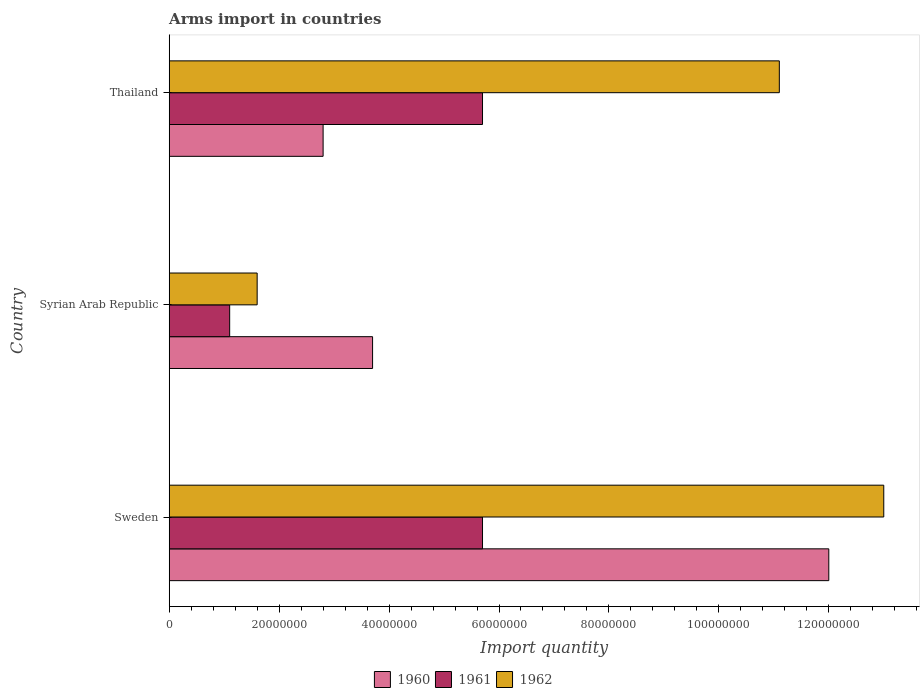How many bars are there on the 1st tick from the top?
Make the answer very short. 3. What is the label of the 3rd group of bars from the top?
Offer a terse response. Sweden. In how many cases, is the number of bars for a given country not equal to the number of legend labels?
Offer a terse response. 0. What is the total arms import in 1960 in Thailand?
Your answer should be very brief. 2.80e+07. Across all countries, what is the maximum total arms import in 1960?
Ensure brevity in your answer.  1.20e+08. Across all countries, what is the minimum total arms import in 1960?
Offer a terse response. 2.80e+07. In which country was the total arms import in 1962 minimum?
Your response must be concise. Syrian Arab Republic. What is the total total arms import in 1960 in the graph?
Your answer should be compact. 1.85e+08. What is the difference between the total arms import in 1962 in Thailand and the total arms import in 1960 in Syrian Arab Republic?
Make the answer very short. 7.40e+07. What is the average total arms import in 1961 per country?
Provide a succinct answer. 4.17e+07. What is the difference between the total arms import in 1960 and total arms import in 1962 in Thailand?
Make the answer very short. -8.30e+07. In how many countries, is the total arms import in 1960 greater than 120000000 ?
Provide a short and direct response. 0. What is the ratio of the total arms import in 1962 in Syrian Arab Republic to that in Thailand?
Offer a terse response. 0.14. What is the difference between the highest and the second highest total arms import in 1960?
Keep it short and to the point. 8.30e+07. What is the difference between the highest and the lowest total arms import in 1960?
Your answer should be compact. 9.20e+07. In how many countries, is the total arms import in 1962 greater than the average total arms import in 1962 taken over all countries?
Offer a very short reply. 2. Is the sum of the total arms import in 1961 in Sweden and Thailand greater than the maximum total arms import in 1962 across all countries?
Your answer should be very brief. No. How many bars are there?
Your response must be concise. 9. What is the difference between two consecutive major ticks on the X-axis?
Your response must be concise. 2.00e+07. Does the graph contain grids?
Your answer should be very brief. No. Where does the legend appear in the graph?
Ensure brevity in your answer.  Bottom center. How many legend labels are there?
Ensure brevity in your answer.  3. How are the legend labels stacked?
Your answer should be very brief. Horizontal. What is the title of the graph?
Offer a very short reply. Arms import in countries. What is the label or title of the X-axis?
Offer a very short reply. Import quantity. What is the label or title of the Y-axis?
Your response must be concise. Country. What is the Import quantity of 1960 in Sweden?
Your response must be concise. 1.20e+08. What is the Import quantity of 1961 in Sweden?
Make the answer very short. 5.70e+07. What is the Import quantity in 1962 in Sweden?
Provide a short and direct response. 1.30e+08. What is the Import quantity in 1960 in Syrian Arab Republic?
Provide a short and direct response. 3.70e+07. What is the Import quantity in 1961 in Syrian Arab Republic?
Give a very brief answer. 1.10e+07. What is the Import quantity of 1962 in Syrian Arab Republic?
Offer a very short reply. 1.60e+07. What is the Import quantity of 1960 in Thailand?
Provide a succinct answer. 2.80e+07. What is the Import quantity of 1961 in Thailand?
Your answer should be compact. 5.70e+07. What is the Import quantity in 1962 in Thailand?
Ensure brevity in your answer.  1.11e+08. Across all countries, what is the maximum Import quantity in 1960?
Give a very brief answer. 1.20e+08. Across all countries, what is the maximum Import quantity in 1961?
Your answer should be very brief. 5.70e+07. Across all countries, what is the maximum Import quantity of 1962?
Make the answer very short. 1.30e+08. Across all countries, what is the minimum Import quantity of 1960?
Your response must be concise. 2.80e+07. Across all countries, what is the minimum Import quantity of 1961?
Your answer should be compact. 1.10e+07. Across all countries, what is the minimum Import quantity in 1962?
Ensure brevity in your answer.  1.60e+07. What is the total Import quantity in 1960 in the graph?
Offer a terse response. 1.85e+08. What is the total Import quantity of 1961 in the graph?
Keep it short and to the point. 1.25e+08. What is the total Import quantity in 1962 in the graph?
Give a very brief answer. 2.57e+08. What is the difference between the Import quantity of 1960 in Sweden and that in Syrian Arab Republic?
Make the answer very short. 8.30e+07. What is the difference between the Import quantity of 1961 in Sweden and that in Syrian Arab Republic?
Make the answer very short. 4.60e+07. What is the difference between the Import quantity in 1962 in Sweden and that in Syrian Arab Republic?
Offer a terse response. 1.14e+08. What is the difference between the Import quantity of 1960 in Sweden and that in Thailand?
Make the answer very short. 9.20e+07. What is the difference between the Import quantity in 1962 in Sweden and that in Thailand?
Ensure brevity in your answer.  1.90e+07. What is the difference between the Import quantity of 1960 in Syrian Arab Republic and that in Thailand?
Provide a succinct answer. 9.00e+06. What is the difference between the Import quantity in 1961 in Syrian Arab Republic and that in Thailand?
Your answer should be compact. -4.60e+07. What is the difference between the Import quantity in 1962 in Syrian Arab Republic and that in Thailand?
Provide a short and direct response. -9.50e+07. What is the difference between the Import quantity in 1960 in Sweden and the Import quantity in 1961 in Syrian Arab Republic?
Your answer should be compact. 1.09e+08. What is the difference between the Import quantity in 1960 in Sweden and the Import quantity in 1962 in Syrian Arab Republic?
Offer a very short reply. 1.04e+08. What is the difference between the Import quantity of 1961 in Sweden and the Import quantity of 1962 in Syrian Arab Republic?
Ensure brevity in your answer.  4.10e+07. What is the difference between the Import quantity in 1960 in Sweden and the Import quantity in 1961 in Thailand?
Make the answer very short. 6.30e+07. What is the difference between the Import quantity of 1960 in Sweden and the Import quantity of 1962 in Thailand?
Keep it short and to the point. 9.00e+06. What is the difference between the Import quantity in 1961 in Sweden and the Import quantity in 1962 in Thailand?
Keep it short and to the point. -5.40e+07. What is the difference between the Import quantity of 1960 in Syrian Arab Republic and the Import quantity of 1961 in Thailand?
Give a very brief answer. -2.00e+07. What is the difference between the Import quantity of 1960 in Syrian Arab Republic and the Import quantity of 1962 in Thailand?
Offer a terse response. -7.40e+07. What is the difference between the Import quantity of 1961 in Syrian Arab Republic and the Import quantity of 1962 in Thailand?
Provide a short and direct response. -1.00e+08. What is the average Import quantity of 1960 per country?
Keep it short and to the point. 6.17e+07. What is the average Import quantity of 1961 per country?
Your response must be concise. 4.17e+07. What is the average Import quantity in 1962 per country?
Provide a succinct answer. 8.57e+07. What is the difference between the Import quantity of 1960 and Import quantity of 1961 in Sweden?
Provide a short and direct response. 6.30e+07. What is the difference between the Import quantity of 1960 and Import quantity of 1962 in Sweden?
Provide a succinct answer. -1.00e+07. What is the difference between the Import quantity in 1961 and Import quantity in 1962 in Sweden?
Your response must be concise. -7.30e+07. What is the difference between the Import quantity in 1960 and Import quantity in 1961 in Syrian Arab Republic?
Give a very brief answer. 2.60e+07. What is the difference between the Import quantity in 1960 and Import quantity in 1962 in Syrian Arab Republic?
Provide a succinct answer. 2.10e+07. What is the difference between the Import quantity in 1961 and Import quantity in 1962 in Syrian Arab Republic?
Provide a short and direct response. -5.00e+06. What is the difference between the Import quantity of 1960 and Import quantity of 1961 in Thailand?
Offer a very short reply. -2.90e+07. What is the difference between the Import quantity in 1960 and Import quantity in 1962 in Thailand?
Make the answer very short. -8.30e+07. What is the difference between the Import quantity in 1961 and Import quantity in 1962 in Thailand?
Your answer should be very brief. -5.40e+07. What is the ratio of the Import quantity in 1960 in Sweden to that in Syrian Arab Republic?
Provide a short and direct response. 3.24. What is the ratio of the Import quantity of 1961 in Sweden to that in Syrian Arab Republic?
Offer a terse response. 5.18. What is the ratio of the Import quantity in 1962 in Sweden to that in Syrian Arab Republic?
Offer a terse response. 8.12. What is the ratio of the Import quantity in 1960 in Sweden to that in Thailand?
Make the answer very short. 4.29. What is the ratio of the Import quantity in 1961 in Sweden to that in Thailand?
Your answer should be compact. 1. What is the ratio of the Import quantity in 1962 in Sweden to that in Thailand?
Give a very brief answer. 1.17. What is the ratio of the Import quantity in 1960 in Syrian Arab Republic to that in Thailand?
Give a very brief answer. 1.32. What is the ratio of the Import quantity in 1961 in Syrian Arab Republic to that in Thailand?
Provide a succinct answer. 0.19. What is the ratio of the Import quantity in 1962 in Syrian Arab Republic to that in Thailand?
Offer a very short reply. 0.14. What is the difference between the highest and the second highest Import quantity in 1960?
Your answer should be very brief. 8.30e+07. What is the difference between the highest and the second highest Import quantity in 1962?
Keep it short and to the point. 1.90e+07. What is the difference between the highest and the lowest Import quantity of 1960?
Keep it short and to the point. 9.20e+07. What is the difference between the highest and the lowest Import quantity in 1961?
Offer a terse response. 4.60e+07. What is the difference between the highest and the lowest Import quantity of 1962?
Give a very brief answer. 1.14e+08. 